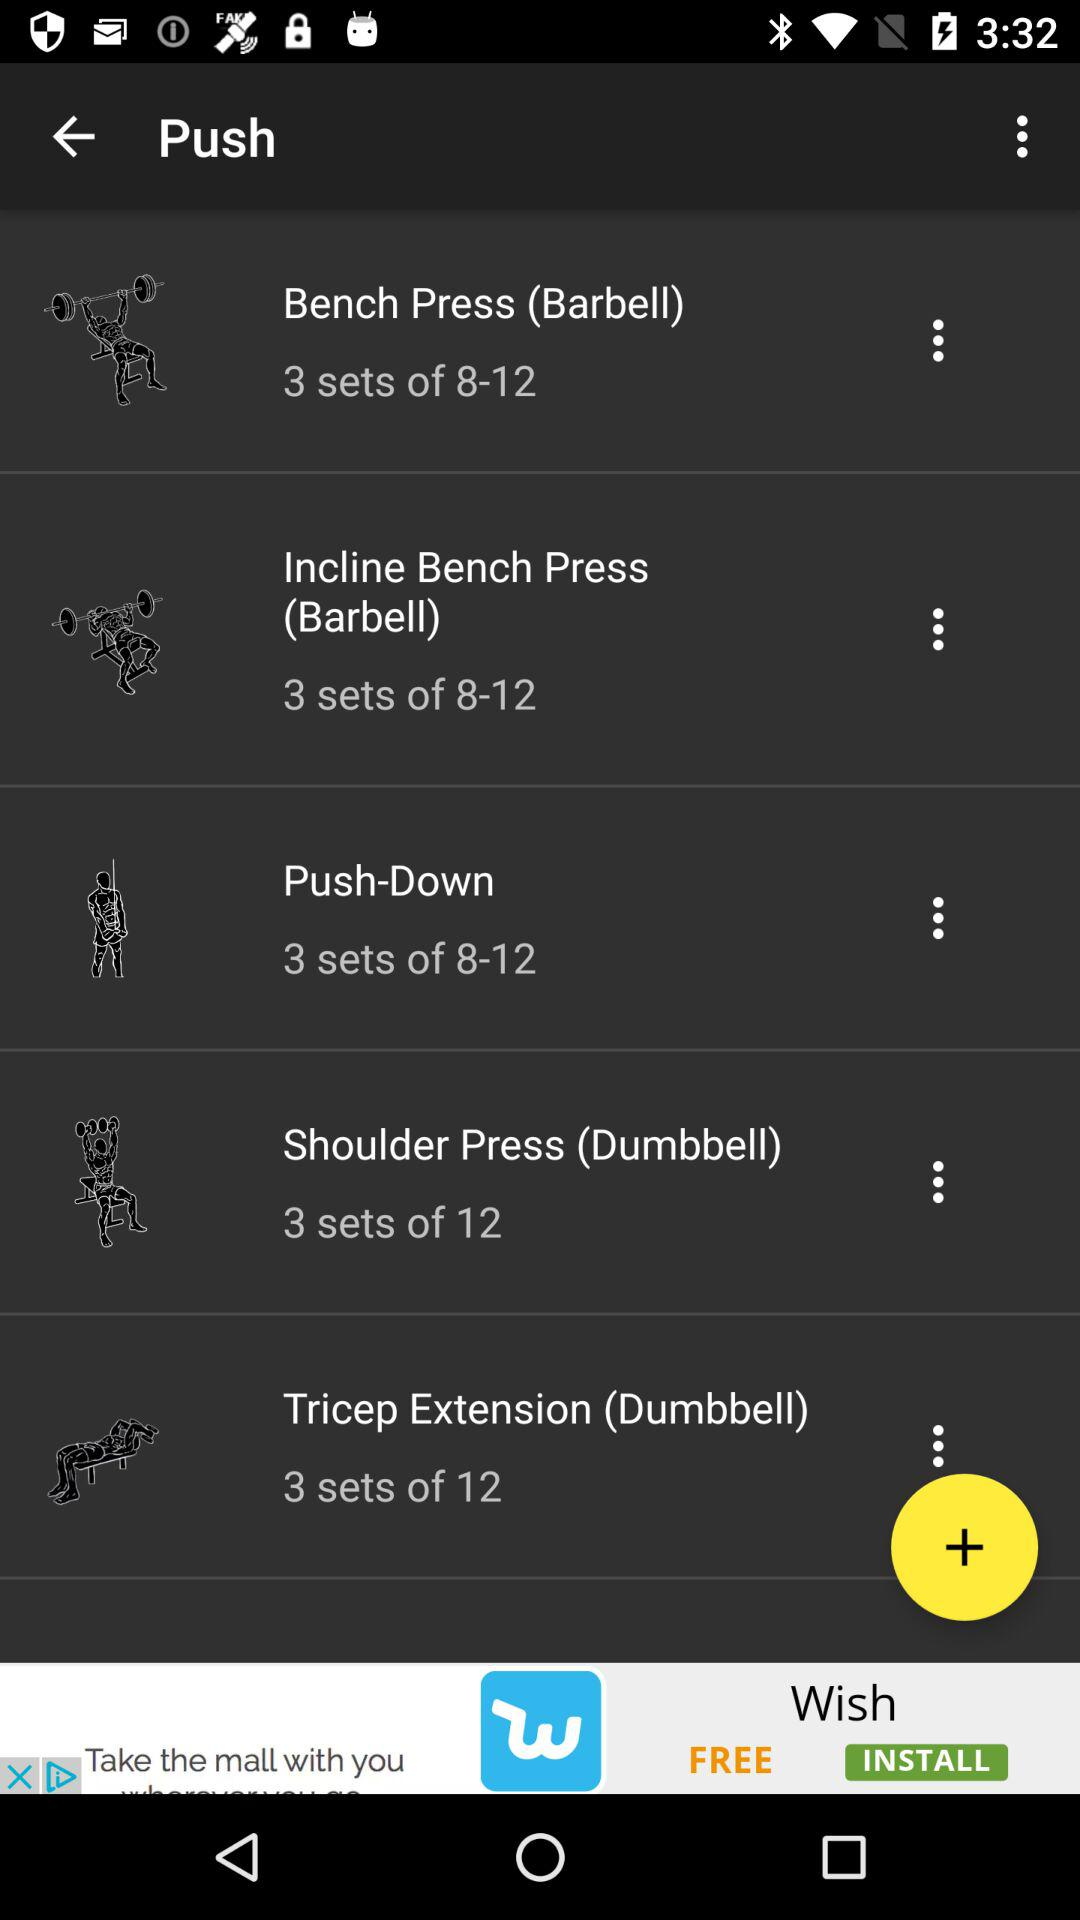How many tricep extension (dumbbell) sets are allowed in total? The total number of tricep extension (dumbbell) sets allowed is 12. 